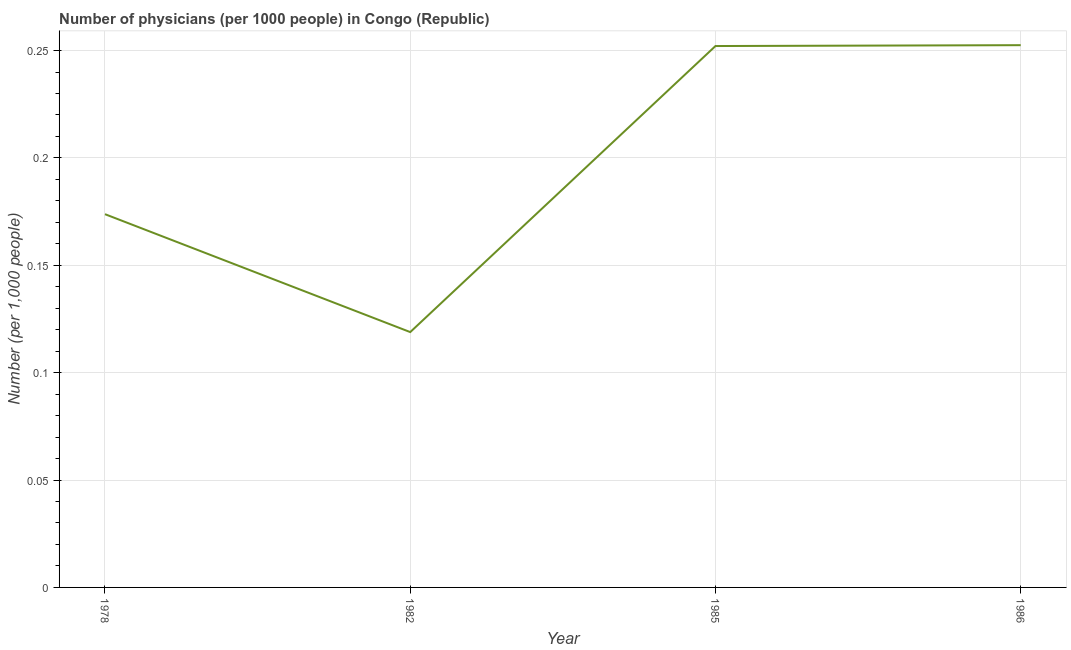What is the number of physicians in 1986?
Your response must be concise. 0.25. Across all years, what is the maximum number of physicians?
Provide a short and direct response. 0.25. Across all years, what is the minimum number of physicians?
Keep it short and to the point. 0.12. What is the sum of the number of physicians?
Offer a terse response. 0.8. What is the difference between the number of physicians in 1982 and 1986?
Keep it short and to the point. -0.13. What is the average number of physicians per year?
Your answer should be compact. 0.2. What is the median number of physicians?
Your answer should be compact. 0.21. In how many years, is the number of physicians greater than 0.02 ?
Offer a terse response. 4. Do a majority of the years between 1982 and 1978 (inclusive) have number of physicians greater than 0.15000000000000002 ?
Your answer should be compact. No. What is the ratio of the number of physicians in 1982 to that in 1986?
Keep it short and to the point. 0.47. Is the difference between the number of physicians in 1985 and 1986 greater than the difference between any two years?
Give a very brief answer. No. What is the difference between the highest and the second highest number of physicians?
Provide a succinct answer. 0. Is the sum of the number of physicians in 1982 and 1986 greater than the maximum number of physicians across all years?
Offer a terse response. Yes. What is the difference between the highest and the lowest number of physicians?
Offer a very short reply. 0.13. In how many years, is the number of physicians greater than the average number of physicians taken over all years?
Your answer should be very brief. 2. How many lines are there?
Provide a short and direct response. 1. Are the values on the major ticks of Y-axis written in scientific E-notation?
Make the answer very short. No. What is the title of the graph?
Make the answer very short. Number of physicians (per 1000 people) in Congo (Republic). What is the label or title of the Y-axis?
Offer a terse response. Number (per 1,0 people). What is the Number (per 1,000 people) in 1978?
Provide a short and direct response. 0.17. What is the Number (per 1,000 people) of 1982?
Your answer should be very brief. 0.12. What is the Number (per 1,000 people) of 1985?
Provide a succinct answer. 0.25. What is the Number (per 1,000 people) of 1986?
Your response must be concise. 0.25. What is the difference between the Number (per 1,000 people) in 1978 and 1982?
Offer a terse response. 0.05. What is the difference between the Number (per 1,000 people) in 1978 and 1985?
Give a very brief answer. -0.08. What is the difference between the Number (per 1,000 people) in 1978 and 1986?
Make the answer very short. -0.08. What is the difference between the Number (per 1,000 people) in 1982 and 1985?
Offer a very short reply. -0.13. What is the difference between the Number (per 1,000 people) in 1982 and 1986?
Your answer should be very brief. -0.13. What is the difference between the Number (per 1,000 people) in 1985 and 1986?
Provide a short and direct response. -0. What is the ratio of the Number (per 1,000 people) in 1978 to that in 1982?
Your answer should be compact. 1.46. What is the ratio of the Number (per 1,000 people) in 1978 to that in 1985?
Keep it short and to the point. 0.69. What is the ratio of the Number (per 1,000 people) in 1978 to that in 1986?
Ensure brevity in your answer.  0.69. What is the ratio of the Number (per 1,000 people) in 1982 to that in 1985?
Give a very brief answer. 0.47. What is the ratio of the Number (per 1,000 people) in 1982 to that in 1986?
Offer a terse response. 0.47. What is the ratio of the Number (per 1,000 people) in 1985 to that in 1986?
Give a very brief answer. 1. 